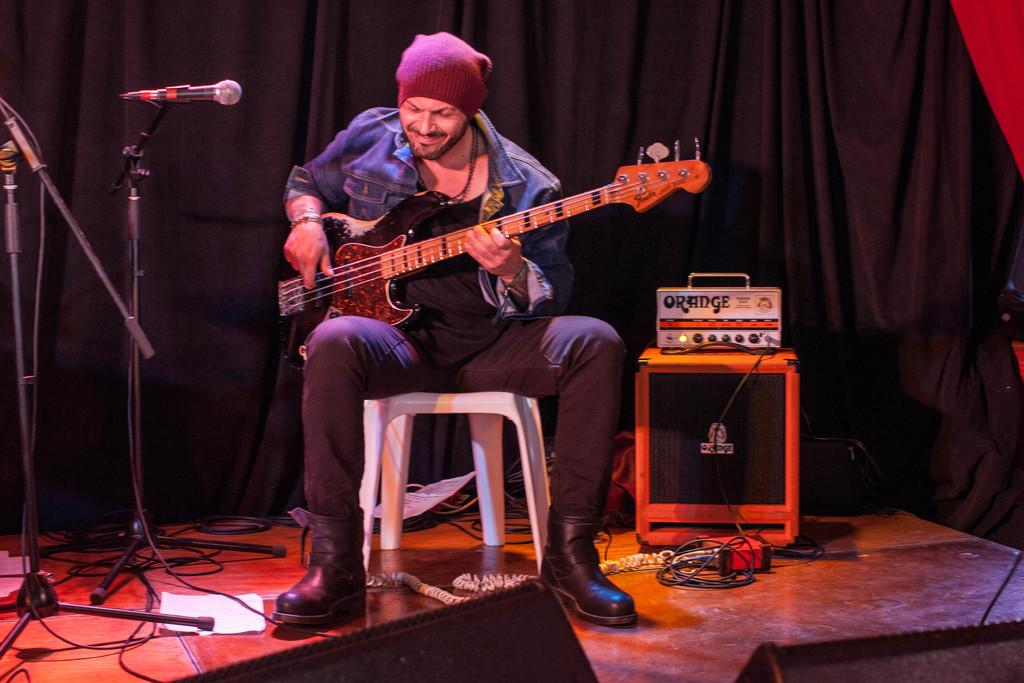What is the person in the image holding? The person is holding a guitar in the image. What can be seen to the left of the person? There is a microphone to the left of the person. What is located to the right of the person? There is a sound box to the right of the person. What type of material is visible in the background of the image? There is a cloth visible in the background of the image. How does the person in the image push the cap off their head? There is no cap present in the image, so it is not possible to answer that question. 